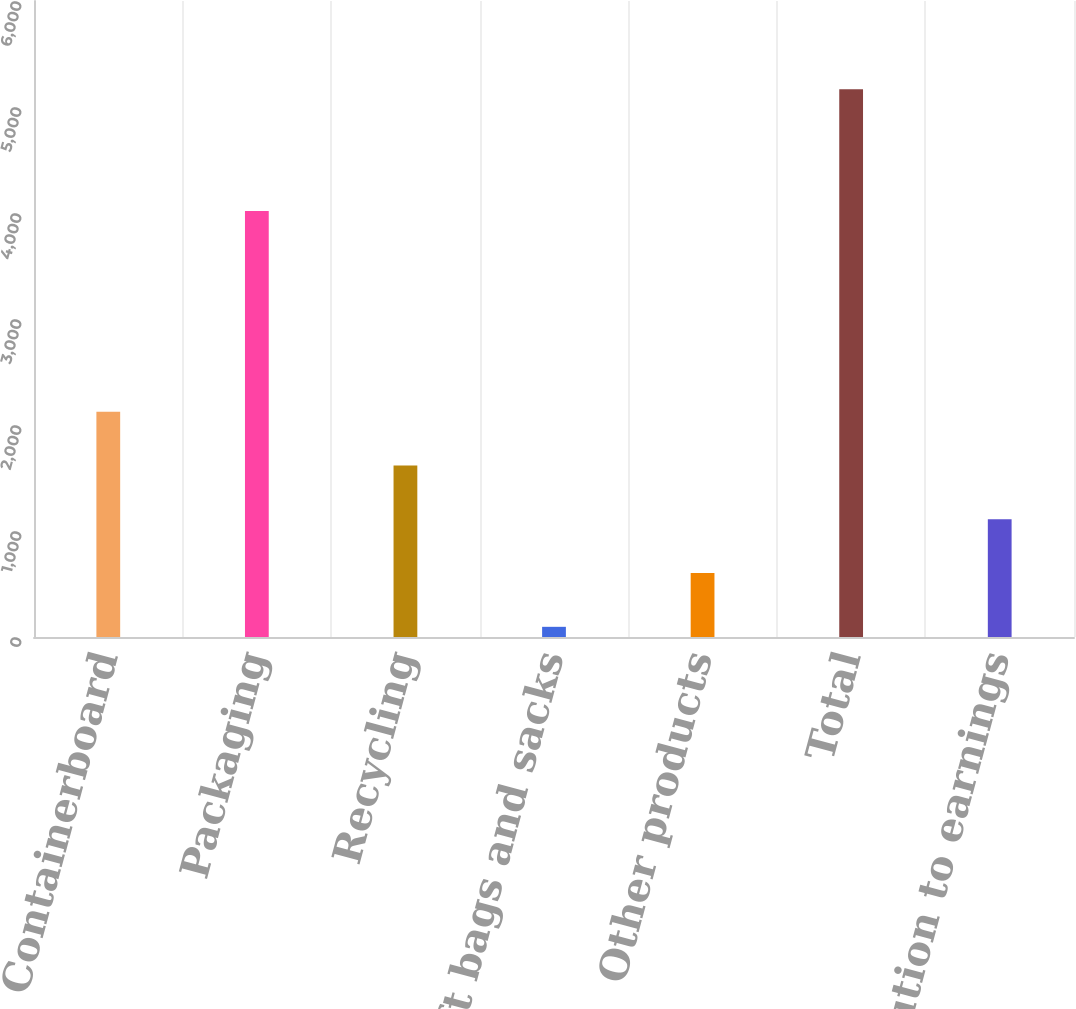Convert chart. <chart><loc_0><loc_0><loc_500><loc_500><bar_chart><fcel>Containerboard<fcel>Packaging<fcel>Recycling<fcel>Kraft bags and sacks<fcel>Other products<fcel>Total<fcel>Contribution to earnings<nl><fcel>2124.8<fcel>4019<fcel>1617.6<fcel>96<fcel>603.2<fcel>5168<fcel>1110.4<nl></chart> 